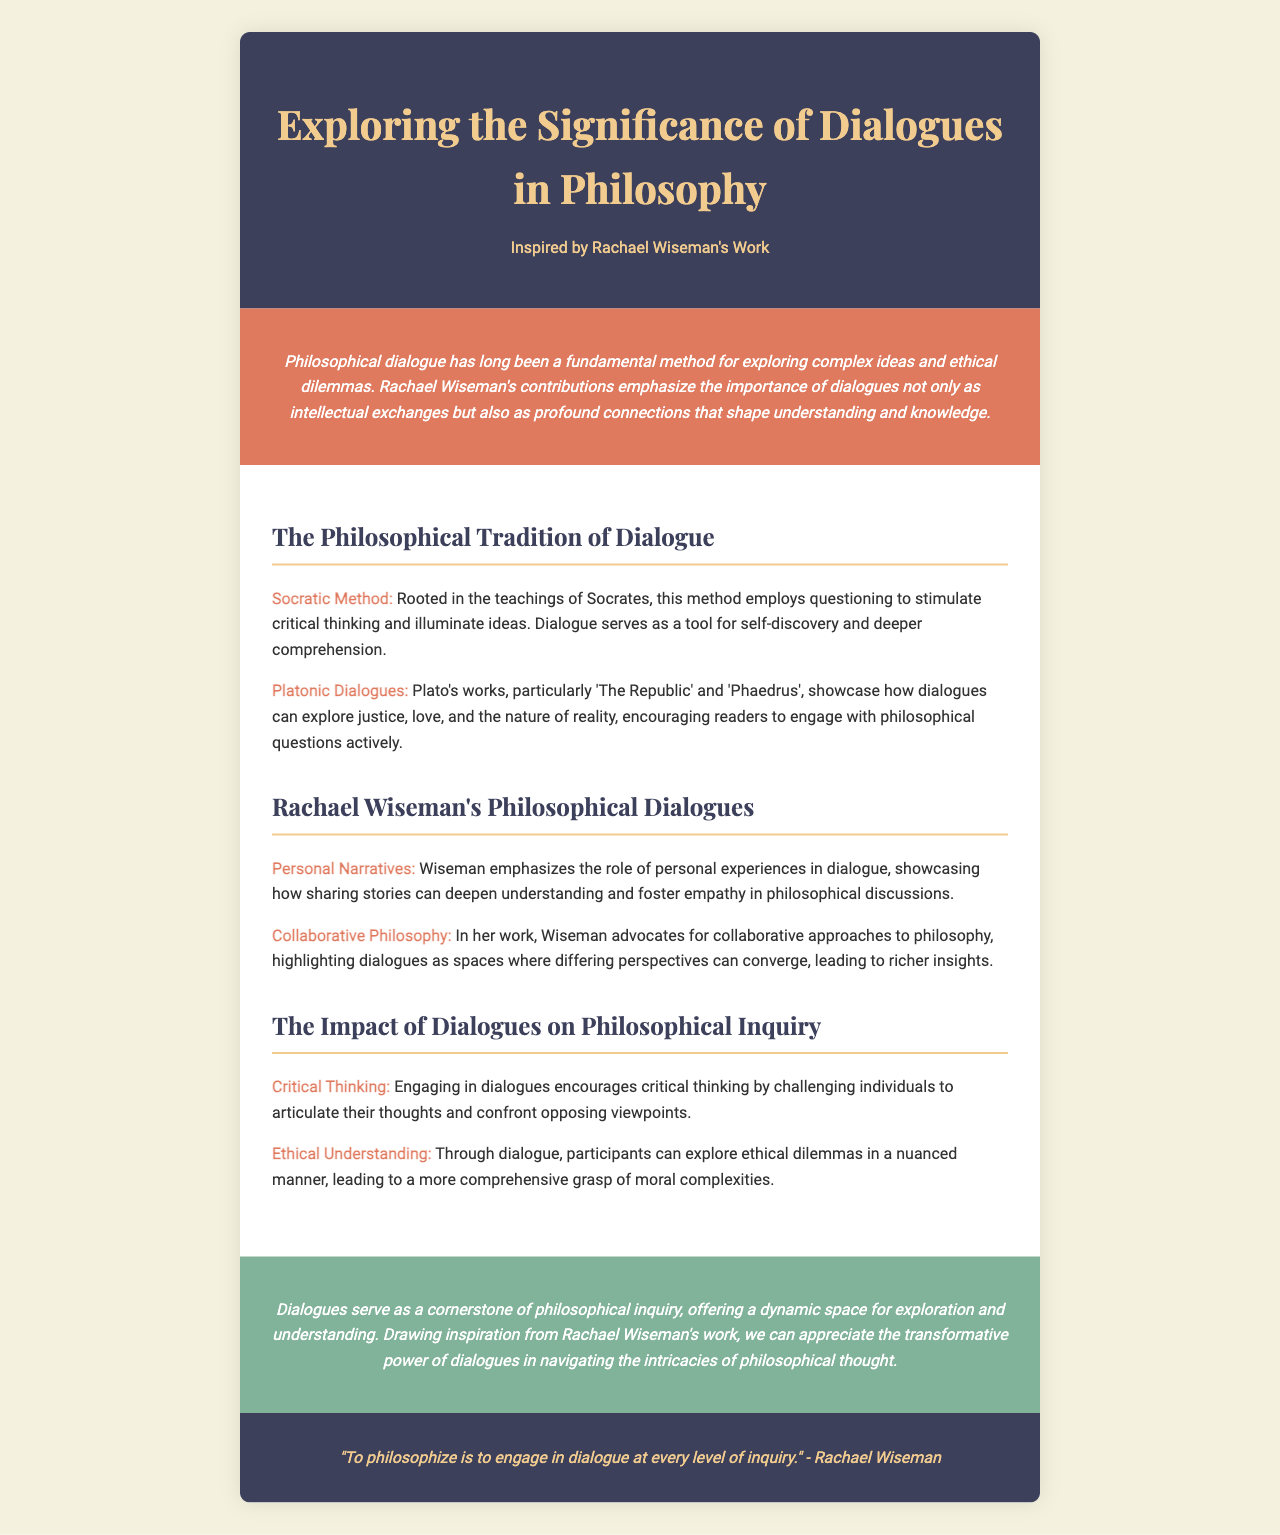What is the title of the brochure? The title of the brochure is presented prominently in the header section, which is "Exploring the Significance of Dialogues in Philosophy."
Answer: Exploring the Significance of Dialogues in Philosophy Who inspired this brochure? The inspiration for the brochure is explicitly stated in the header, mentioning Rachael Wiseman's work.
Answer: Rachael Wiseman What method is rooted in Socratic teachings? The document discusses a specific method that is associated with Socrates, which is called the Socratic Method.
Answer: Socratic Method Which work is specifically mentioned as part of Platonic Dialogues? The brochure includes specific references to Platonic works, notably mentioning 'The Republic.'
Answer: The Republic What concept does Rachael Wiseman emphasize in her dialogues? The content highlights the significance of personal narratives in philosophical discussions as emphasized by Wiseman.
Answer: Personal Narratives What does the brochure state dialogues encourage? The document outlines that engaging in dialogues promotes a specific cognitive skill that is essential in philosophical inquiry.
Answer: Critical Thinking What is described as a cornerstone of philosophical inquiry? The conclusion of the brochure outlines a vital aspect of philosophical exploration, specifically describing dialogues in this manner.
Answer: Dialogues What color scheme is used in the conclusion section? The conclusion section features a specific color that is described as a calming shade and is utilized in the background.
Answer: #81b29a 